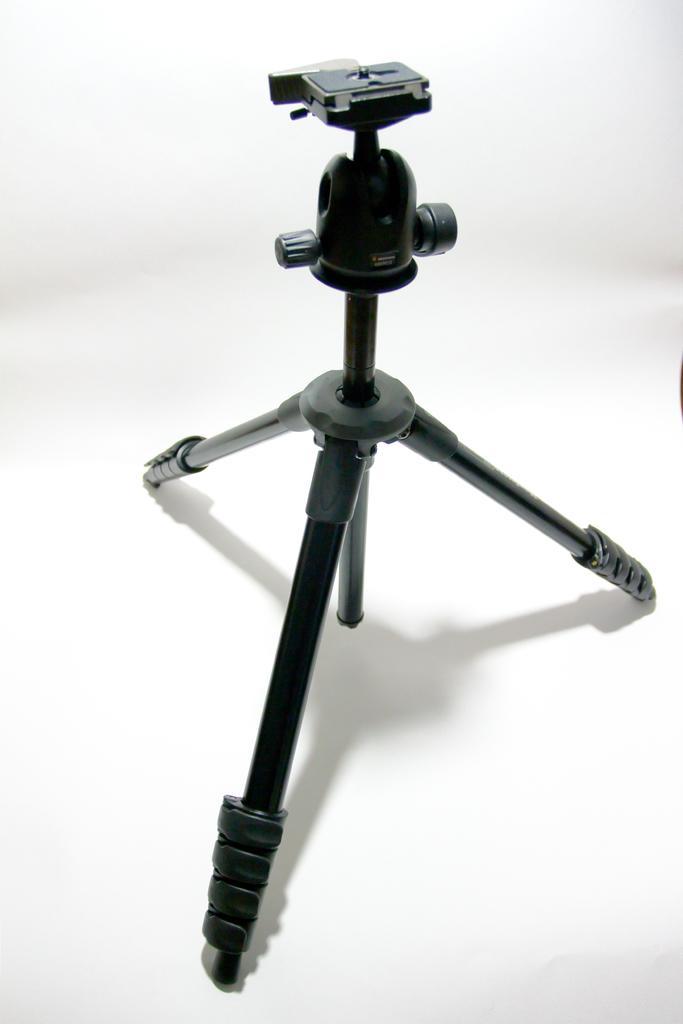Can you describe this image briefly? In this image I can see a camera and camera stand visible and background is white. 